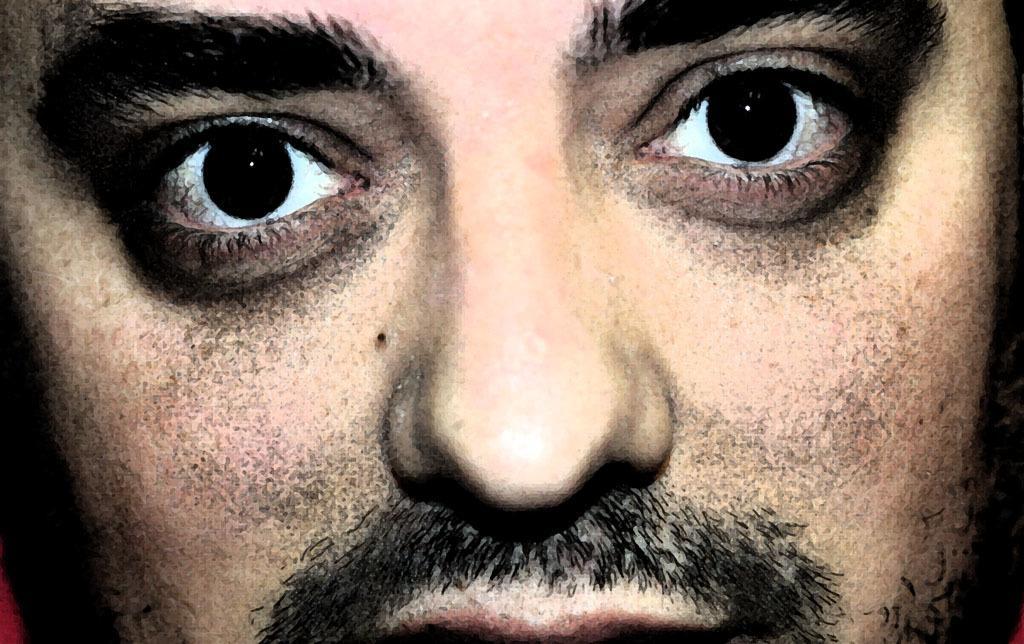Can you describe this image briefly? In this picture, we see the face of the man. We can see the eyes, nose and mouth of the man. This might be an edited image. 